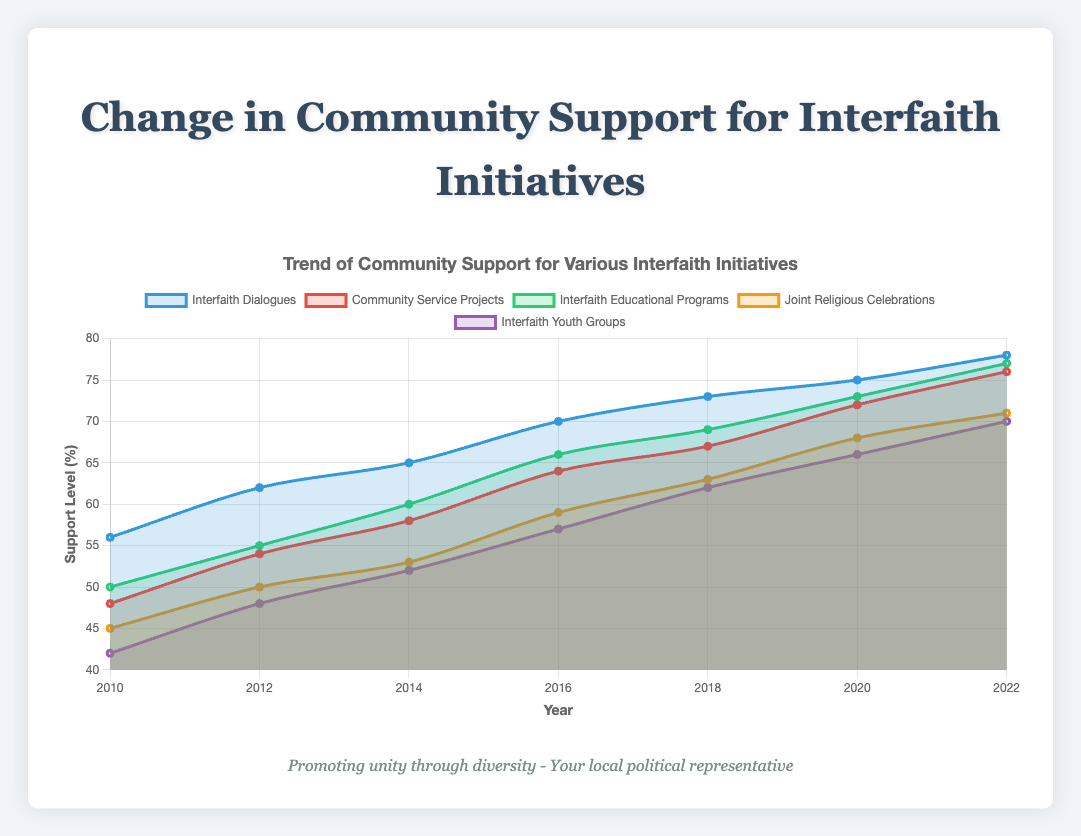Which initiative had the highest level of community support in 2022? By examining the end points of each line in the chart where the year is 2022, we can see which one reaches the highest value. Here, "Interfaith Dialogues" reaches 78, which is the highest.
Answer: Interfaith Dialogues How much did the support for Community Service Projects increase from 2010 to 2022? Subtract the 2010 value from the 2022 value for "Community Service Projects". The support increased from 48 to 76. 76 - 48 = 28.
Answer: 28 Which initiative showed a steady increase in support over time? All initiatives show an increase, but we need to find the one that shows no dips or flat periods. Upon examining the chart, "Interfaith Dialogues" steadily increases without any drops or plateaus.
Answer: Interfaith Dialogues What is the average support level for Interfaith Educational Programs over the years? Add all the values for "Interfaith Educational Programs" and divide by the number of years. (50 + 55 + 60 + 66 + 69 + 73 + 77) / 7 = 450 / 7 ≈ 64.29.
Answer: 64.29 Between which years did Joint Religious Celebrations see the highest rate of increase in support? Look for the steepest slope in the "Joint Religious Celebrations" line. The steepest increase is between 2016 and 2018, where support jumped from 59 to 63, an increase of 4 points.
Answer: 2016 to 2018 Which initiative had the lowest support in 2010, and what was its value? By checking the beginning points of each line in the chart for the year 2010, "Interfaith Youth Groups" had the lowest support at 42.
Answer: Interfaith Youth Groups, 42 How does the support level for Interfaith Youth Groups in 2020 compare to Community Service Projects in the same year? Find the 2020 values for both initiatives: "Interfaith Youth Groups" is at 66, while "Community Service Projects" is at 72. Comparing these, Community Service Projects has higher support.
Answer: Community Service Projects has higher support What is the total increase in support for Joint Religious Celebrations from 2010 to 2022? Subtract the 2010 value from the 2022 value for "Joint Religious Celebrations". The support increased from 45 to 71. 71 - 45 = 26.
Answer: 26 Which initiative had the closest support levels in 2016? Look at the values for each initiative in 2016: Interfaith Dialogues (70), Community Service Projects (64), Interfaith Educational Programs (66), Joint Religious Celebrations (59), Interfaith Youth Groups (57). Interfaith Educational Programs (66) and Community Service Projects (64) are the closest.
Answer: Interfaith Educational Programs and Community Service Projects What was the difference in support between the highest and lowest initiatives in 2014? Look at the 2014 values: Interfaith Dialogues (65), Community Service Projects (58), Interfaith Educational Programs (60), Joint Religious Celebrations (53), Interfaith Youth Groups (52). The highest is Interfaith Dialogues (65) and the lowest is Interfaith Youth Groups (52). The difference is 65 - 52 = 13.
Answer: 13 